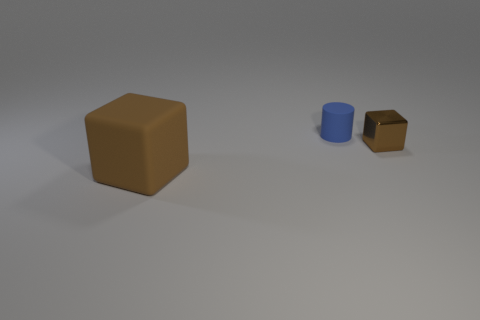Subtract all green cylinders. Subtract all red blocks. How many cylinders are left? 1 Add 1 big brown cubes. How many objects exist? 4 Subtract all blocks. How many objects are left? 1 Subtract all gray blocks. Subtract all brown objects. How many objects are left? 1 Add 3 brown cubes. How many brown cubes are left? 5 Add 2 big green spheres. How many big green spheres exist? 2 Subtract 1 blue cylinders. How many objects are left? 2 